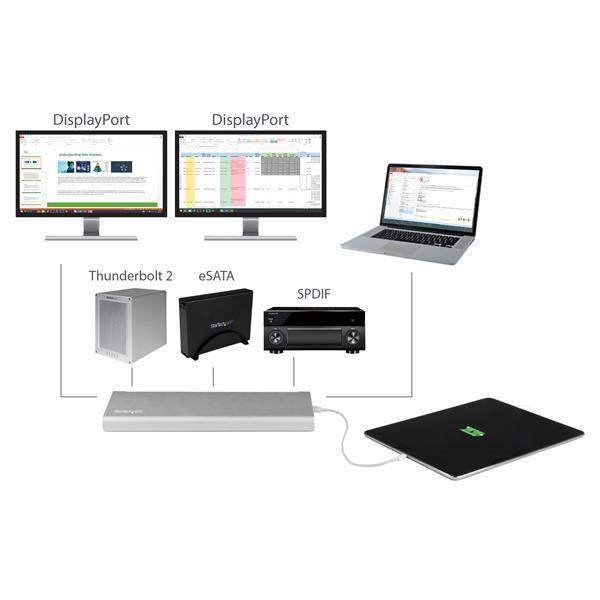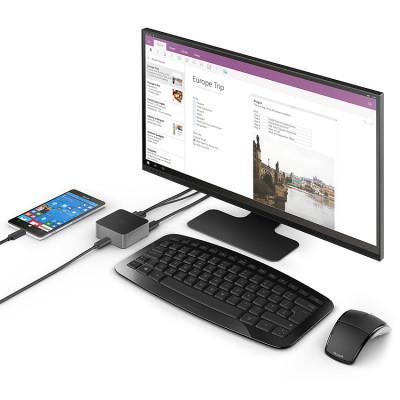The first image is the image on the left, the second image is the image on the right. For the images displayed, is the sentence "In at least one image there are two separate electronic  powered on with a black wireless keyboard in front of the computer monitor." factually correct? Answer yes or no. Yes. The first image is the image on the left, the second image is the image on the right. For the images displayed, is the sentence "there is a monitor with a keyboard in front of it and a mouse to the right of the keyboard" factually correct? Answer yes or no. Yes. 